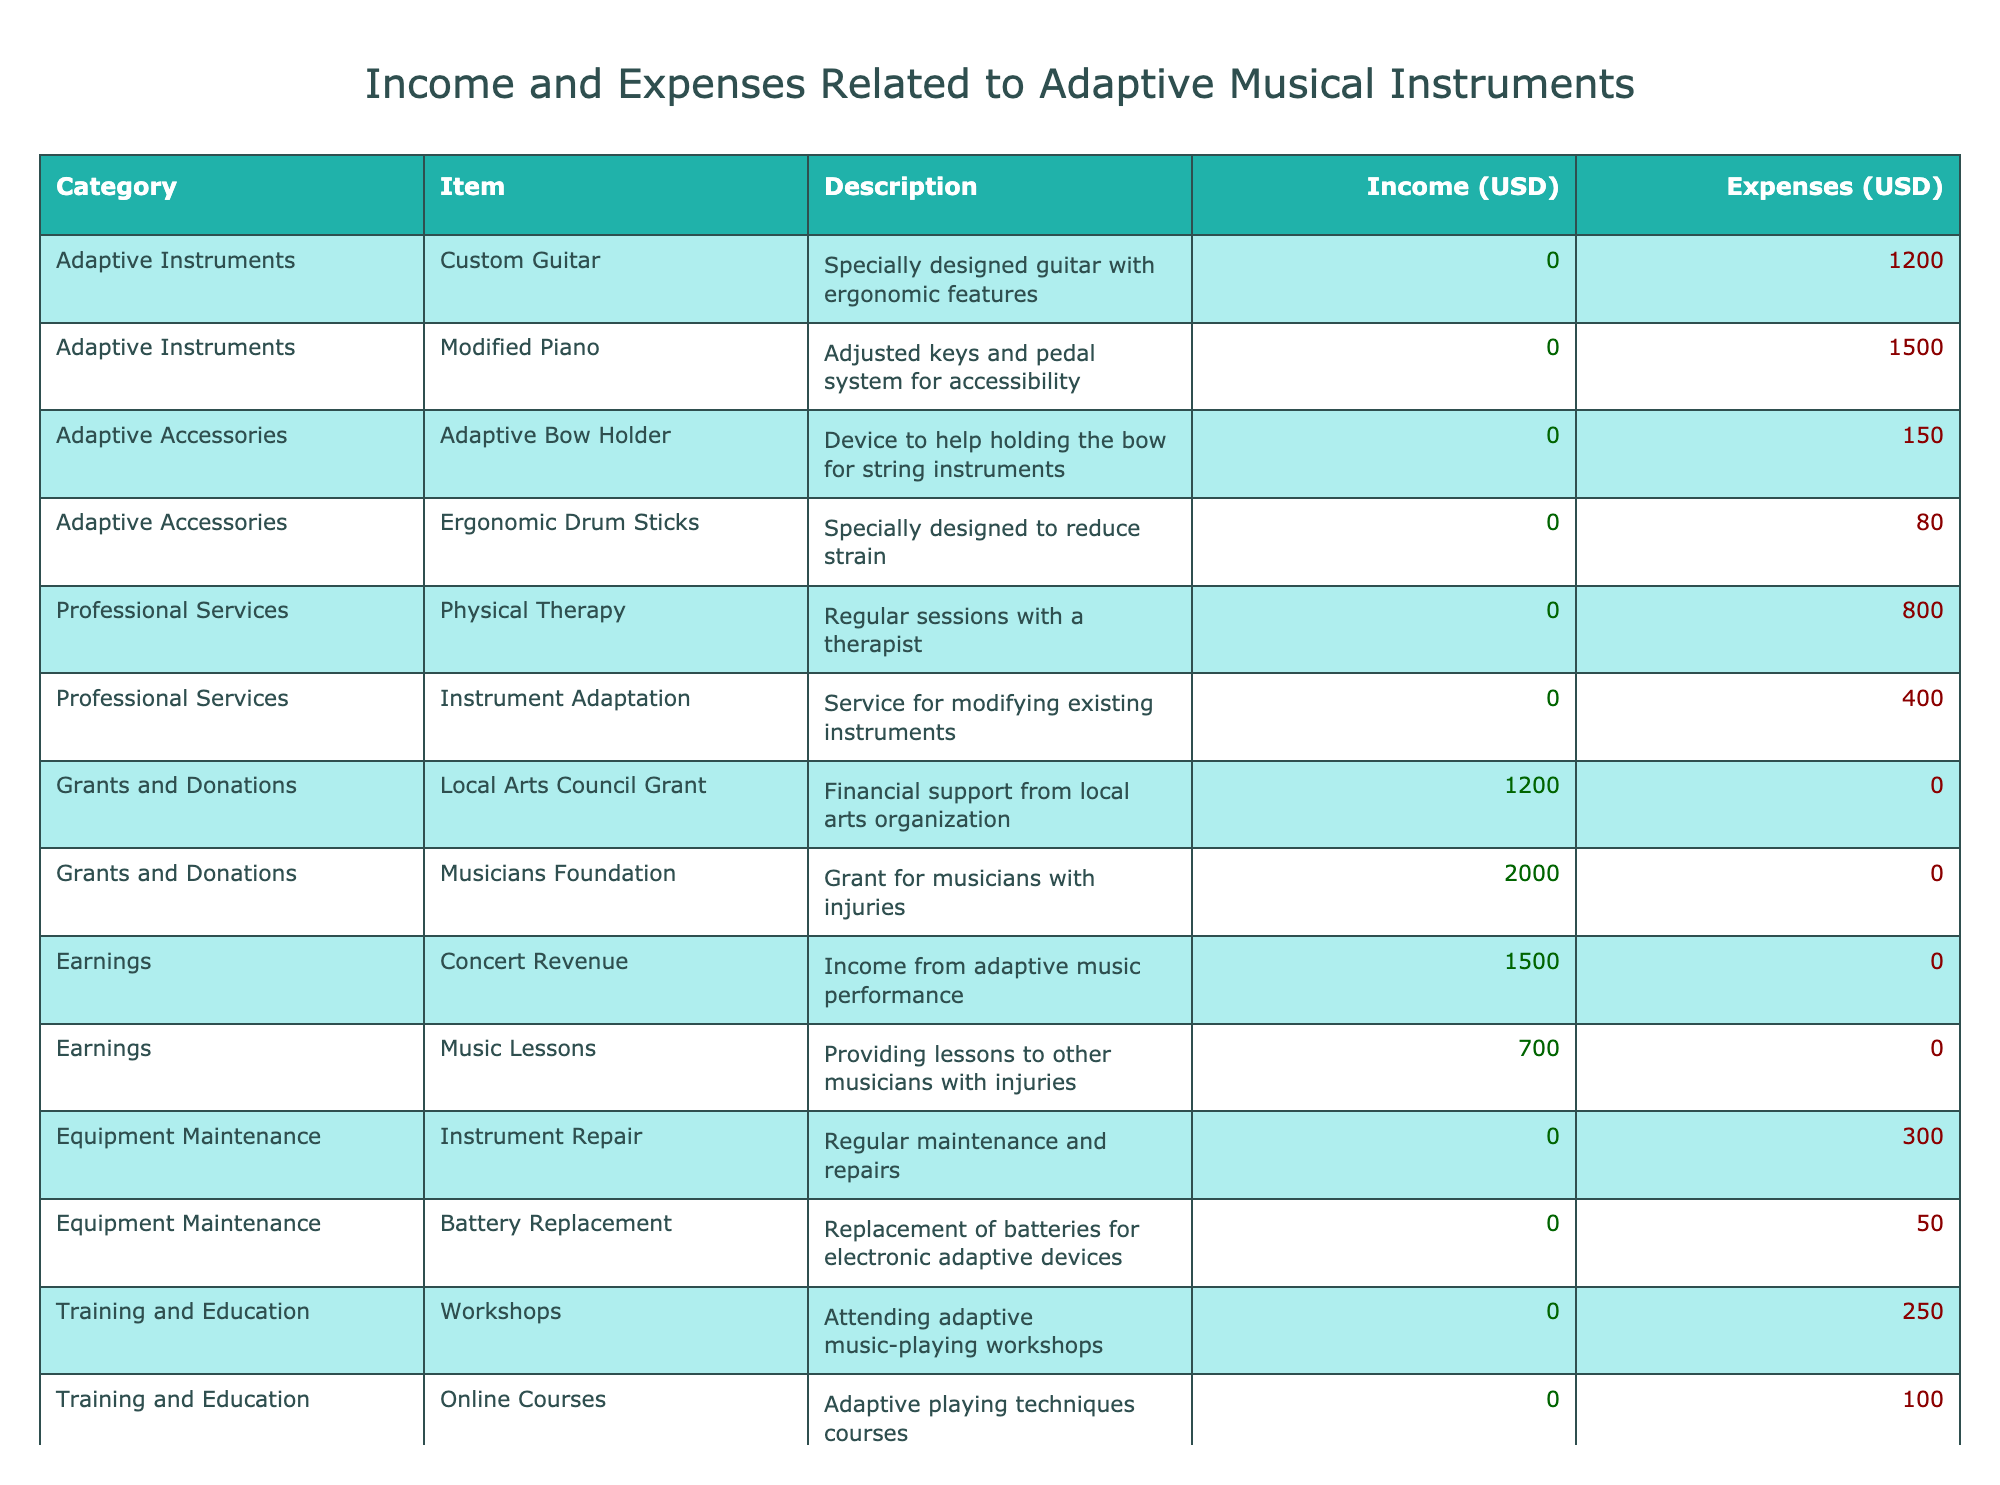What is the total income from grants and donations? There are two entries under grants and donations: "Local Arts Council Grant" with an income of 1200 USD and "Musicians Foundation" with an income of 2000 USD. Adding these together, 1200 + 2000 = 3200 USD.
Answer: 3200 USD What is the total expense for adaptive instruments? There are two instruments listed as adaptive instruments: "Custom Guitar" with an expense of 1200 USD and "Modified Piano" with an expense of 1500 USD. Adding these amounts together gives 1200 + 1500 = 2700 USD for adaptive instruments.
Answer: 2700 USD Is there any income generated from professional services? There is one entry under professional services, "Physical Therapy," which has no income recorded (0 USD), and "Instrument Adaptation," also has no income (0 USD). Therefore, the total income from professional services is 0 USD.
Answer: No What are the total earnings from concerts and music lessons? The total earnings consist of concert revenue (1500 USD) and music lessons (700 USD). Adding these amounts together gives: 1500 + 700 = 2200 USD.
Answer: 2200 USD What is the net total (income minus expenses)? The total income is calculated from grants, donations, and earnings, which gives us 3200 + 2200 = 5400 USD. The total expenses amount to 4200 USD. Therefore, the net total is 5400 - 4200 = 1200 USD.
Answer: 1200 USD How much was spent on adaptive accessories? There are two adaptive accessories listed: "Adaptive Bow Holder" (150 USD) and "Ergonomic Drum Sticks" (80 USD). Adding these expenses together gives 150 + 80 = 230 USD for adaptive accessories.
Answer: 230 USD Are any expenses recorded for equipment maintenance? There are two entries under equipment maintenance: "Instrument Repair" (300 USD) and "Battery Replacement" (50 USD), both of which have expenses recorded. Since both have non-zero expenses, it confirms that there are expenses recorded for equipment maintenance.
Answer: Yes What was the total for training and education expenses? There are two entries under training and education: "Workshops" (250 USD) and "Online Courses" (100 USD). Adding these expenses gives: 250 + 100 = 350 USD for training and education.
Answer: 350 USD Which category has the highest expense? The category "Adaptive Instruments" has the highest expenses totaling 2700 USD, while the other categories have less. Comparing category expenses: Adaptive Instruments (2700), Professional Services (1200), Adaptive Accessories (230), etc., confirms that Adaptive Instruments have the highest expense.
Answer: Adaptive Instruments 